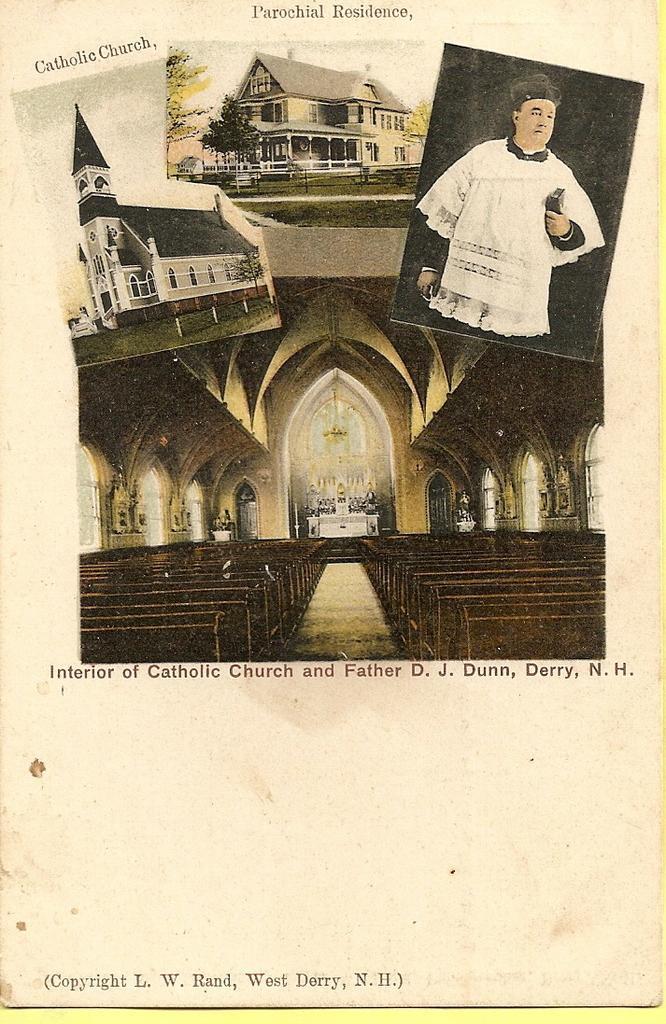In one or two sentences, can you explain what this image depicts? In this picture we can see a paper, on this paper we can see photos of buildings, a person and some text. 